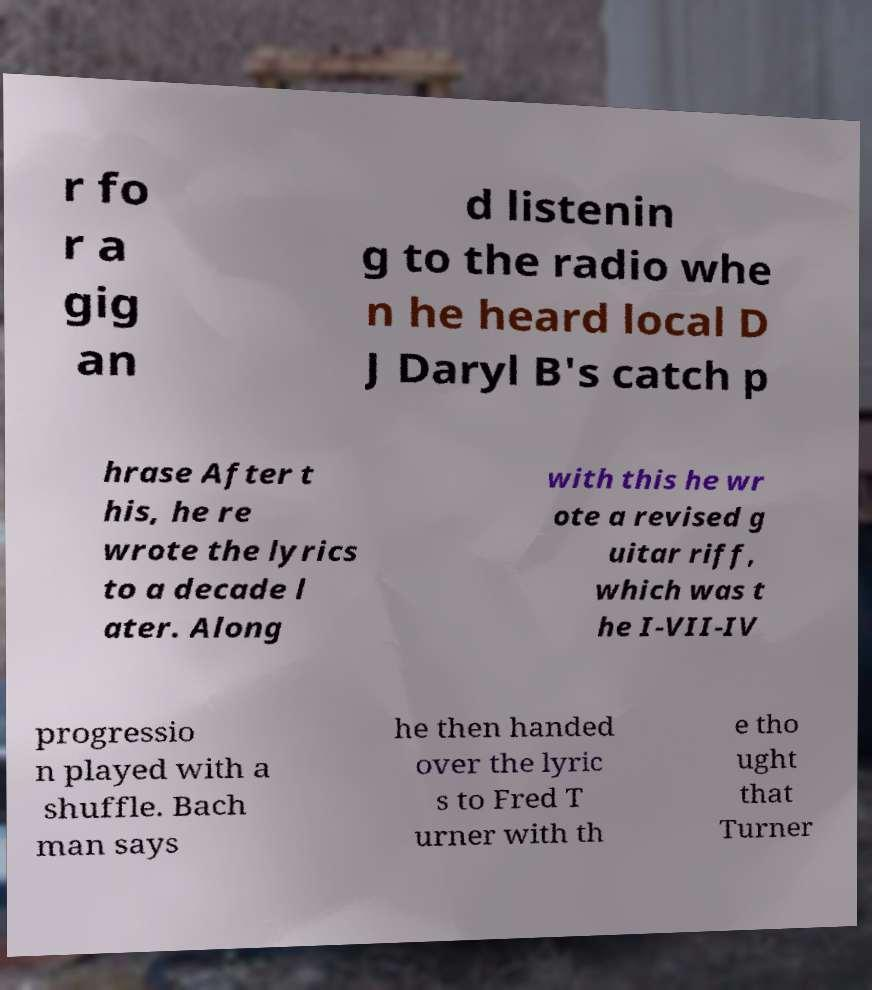Please read and relay the text visible in this image. What does it say? r fo r a gig an d listenin g to the radio whe n he heard local D J Daryl B's catch p hrase After t his, he re wrote the lyrics to a decade l ater. Along with this he wr ote a revised g uitar riff, which was t he I-VII-IV progressio n played with a shuffle. Bach man says he then handed over the lyric s to Fred T urner with th e tho ught that Turner 